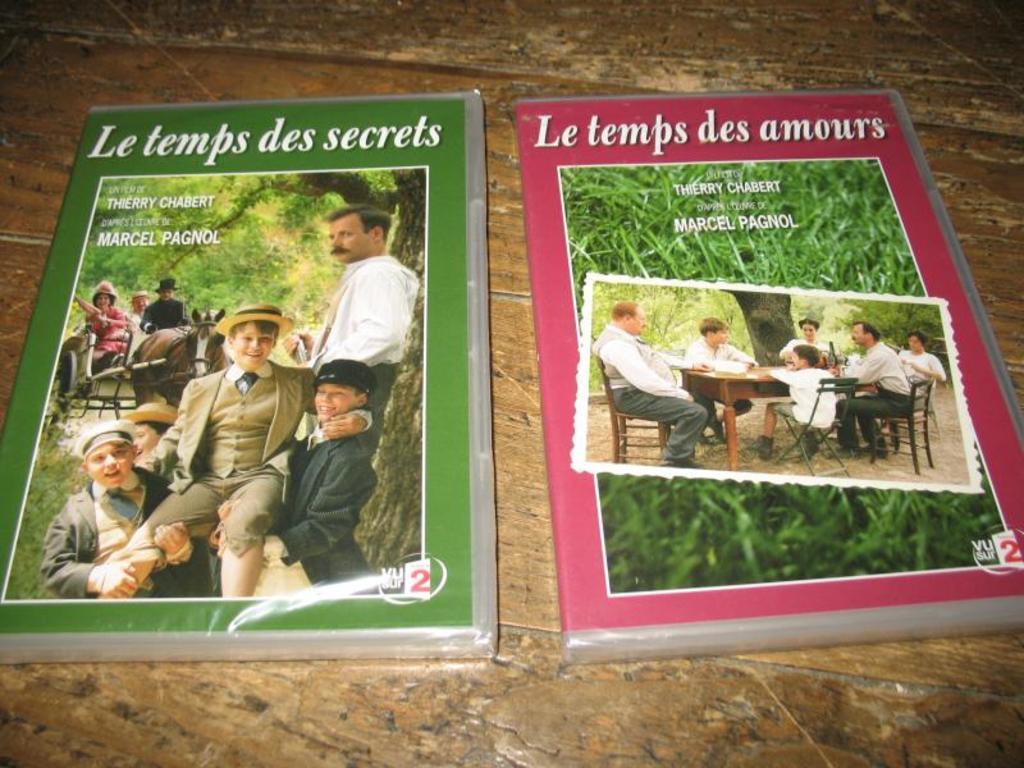How would you summarize this image in a sentence or two? This image consists of two books. One is in green color and another one is in red color. On that books there are photos of people, who are sitting Standing and there is also a table in that picture and chairs too. 